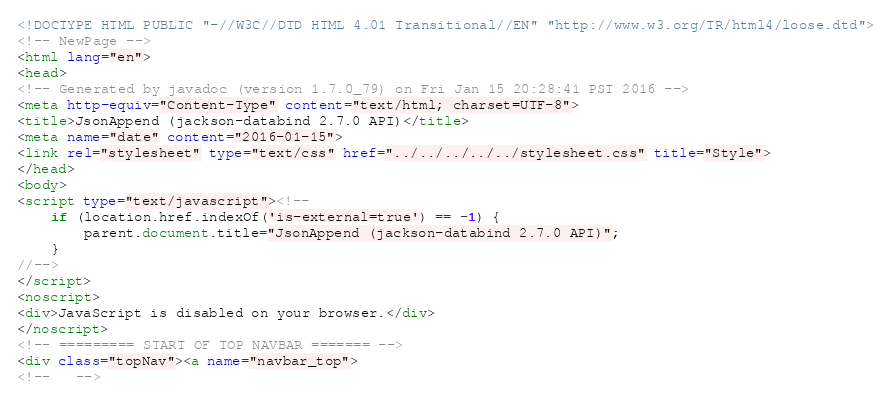Convert code to text. <code><loc_0><loc_0><loc_500><loc_500><_HTML_><!DOCTYPE HTML PUBLIC "-//W3C//DTD HTML 4.01 Transitional//EN" "http://www.w3.org/TR/html4/loose.dtd">
<!-- NewPage -->
<html lang="en">
<head>
<!-- Generated by javadoc (version 1.7.0_79) on Fri Jan 15 20:28:41 PST 2016 -->
<meta http-equiv="Content-Type" content="text/html; charset=UTF-8">
<title>JsonAppend (jackson-databind 2.7.0 API)</title>
<meta name="date" content="2016-01-15">
<link rel="stylesheet" type="text/css" href="../../../../../stylesheet.css" title="Style">
</head>
<body>
<script type="text/javascript"><!--
    if (location.href.indexOf('is-external=true') == -1) {
        parent.document.title="JsonAppend (jackson-databind 2.7.0 API)";
    }
//-->
</script>
<noscript>
<div>JavaScript is disabled on your browser.</div>
</noscript>
<!-- ========= START OF TOP NAVBAR ======= -->
<div class="topNav"><a name="navbar_top">
<!--   --></code> 